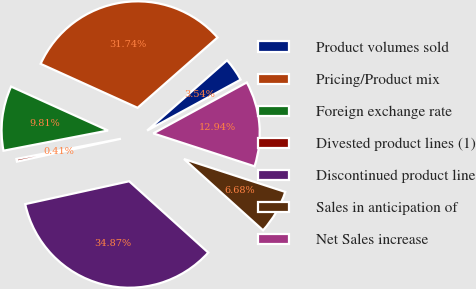<chart> <loc_0><loc_0><loc_500><loc_500><pie_chart><fcel>Product volumes sold<fcel>Pricing/Product mix<fcel>Foreign exchange rate<fcel>Divested product lines (1)<fcel>Discontinued product line<fcel>Sales in anticipation of<fcel>Net Sales increase<nl><fcel>3.54%<fcel>31.74%<fcel>9.81%<fcel>0.41%<fcel>34.87%<fcel>6.68%<fcel>12.94%<nl></chart> 